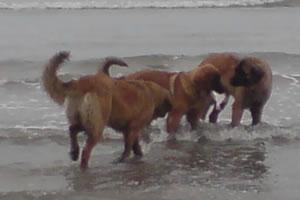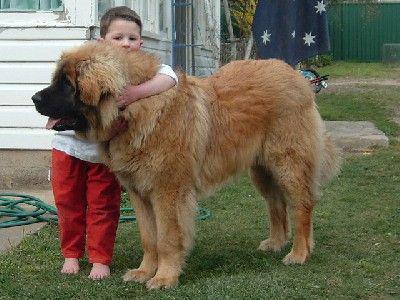The first image is the image on the left, the second image is the image on the right. Considering the images on both sides, is "Each image contains exactly one dog, which is standing in profile." valid? Answer yes or no. No. The first image is the image on the left, the second image is the image on the right. Considering the images on both sides, is "There are at least three dogs  outside." valid? Answer yes or no. Yes. 